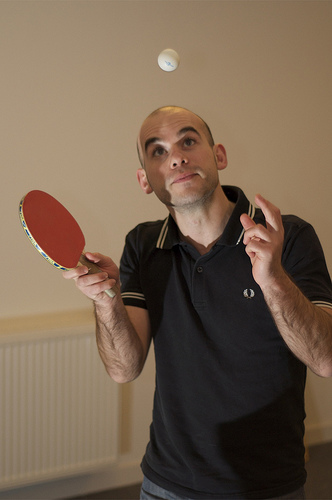<image>
Can you confirm if the pingpong ball is above the head? Yes. The pingpong ball is positioned above the head in the vertical space, higher up in the scene. 